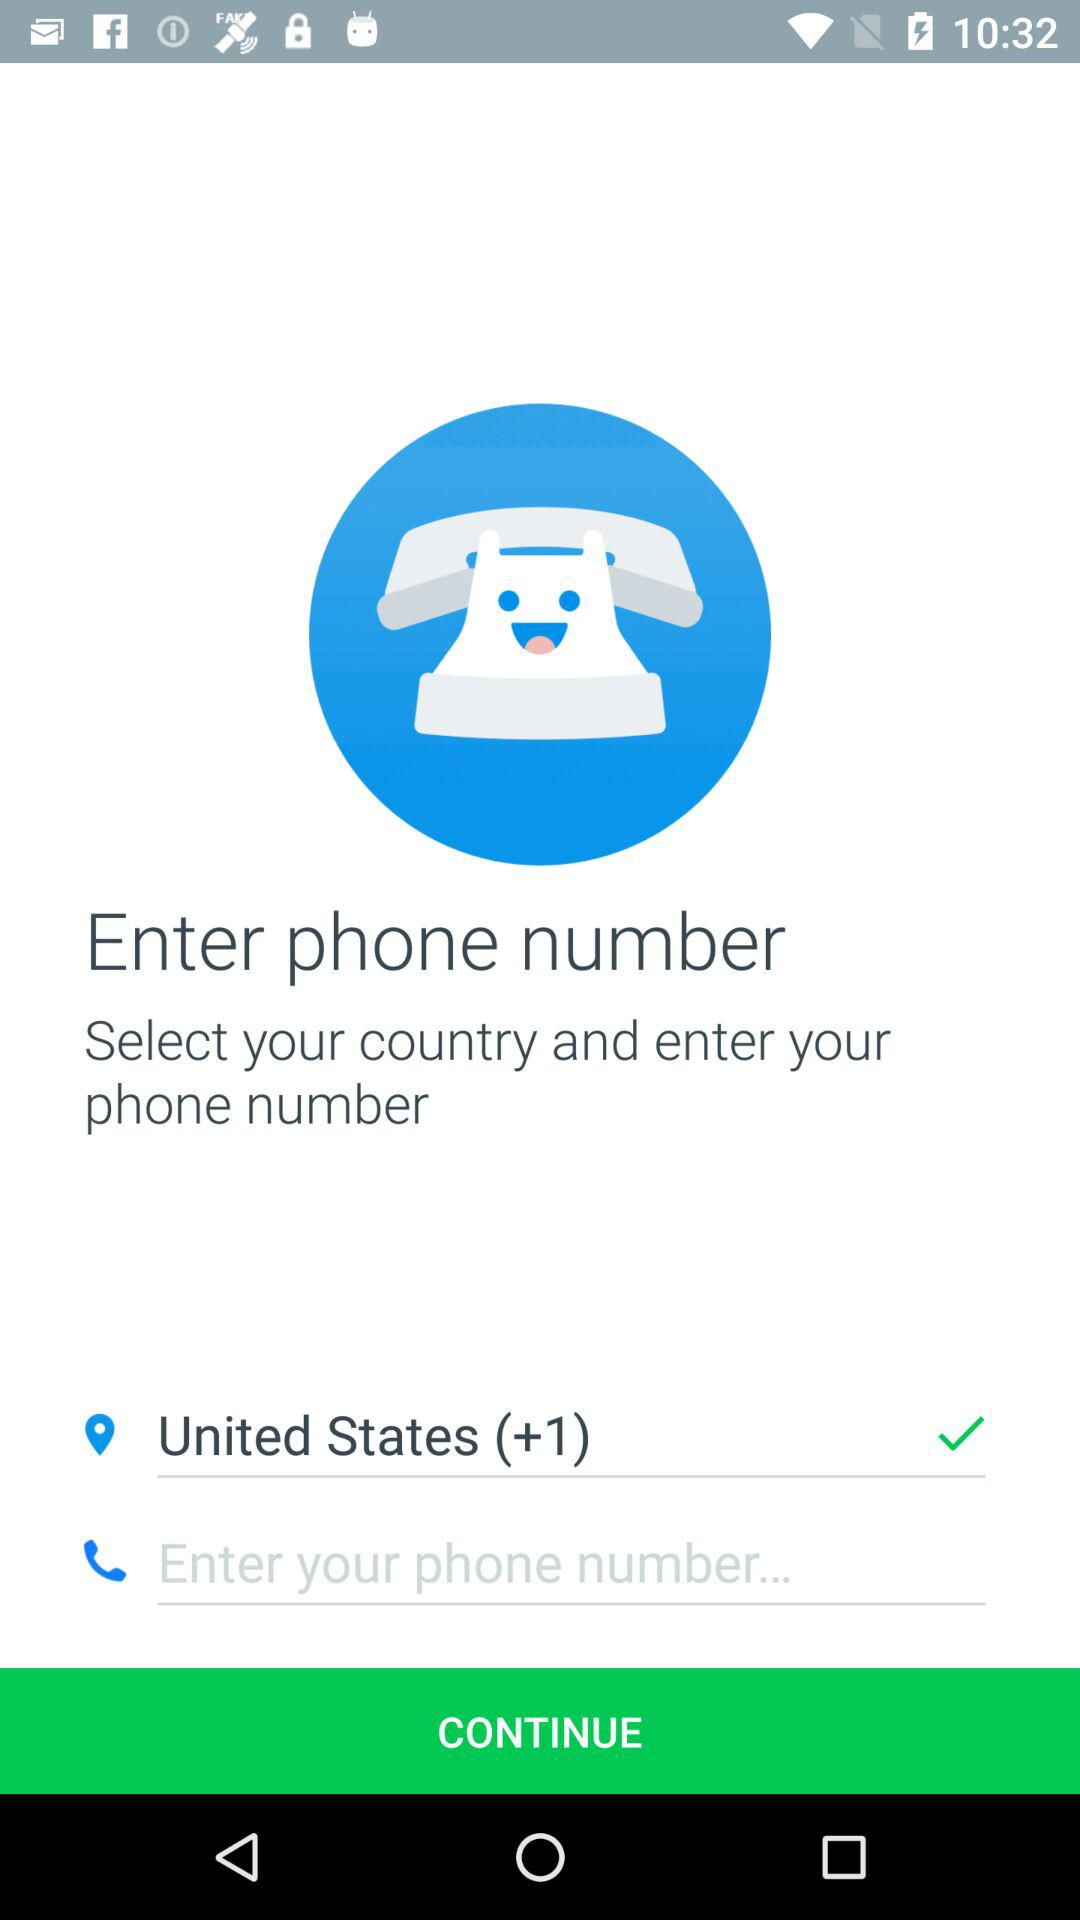How many input fields are there for entering phone numbers?
Answer the question using a single word or phrase. 2 